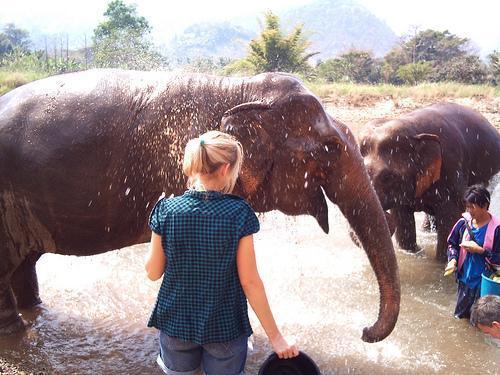How many different kinds of animals are in the photo?
Give a very brief answer. 1. How many people are in the photo?
Give a very brief answer. 2. How many elephants are in the picture?
Give a very brief answer. 2. How many human beings are in the picture?
Give a very brief answer. 2. 